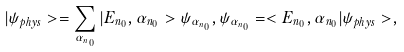<formula> <loc_0><loc_0><loc_500><loc_500>| \psi _ { p h y s } > = \sum _ { \alpha _ { n _ { 0 } } } | E _ { n _ { 0 } } , \alpha _ { n _ { 0 } } > \psi _ { \alpha _ { n _ { 0 } } } , \psi _ { \alpha _ { n _ { 0 } } } = < E _ { n _ { 0 } } , \alpha _ { n _ { 0 } } | \psi _ { p h y s } > ,</formula> 